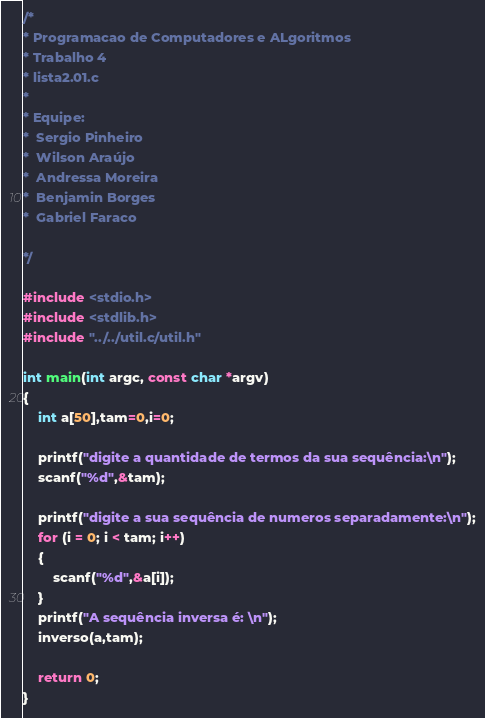<code> <loc_0><loc_0><loc_500><loc_500><_C_>/*
* Programacao de Computadores e ALgoritmos
* Trabalho 4
* lista2.01.c
*
* Equipe:
*  Sergio Pinheiro
*  Wilson Araújo
*  Andressa Moreira
*  Benjamin Borges
*  Gabriel Faraco
      
*/

#include <stdio.h>
#include <stdlib.h>
#include "../../util.c/util.h"

int main(int argc, const char *argv)
{
	int a[50],tam=0,i=0;

	printf("digite a quantidade de termos da sua sequência:\n");
	scanf("%d",&tam);
	
	printf("digite a sua sequência de numeros separadamente:\n");
	for (i = 0; i < tam; i++)
	{
		scanf("%d",&a[i]);
	}
	printf("A sequência inversa é: \n");
	inverso(a,tam);

	return 0;
}
</code> 